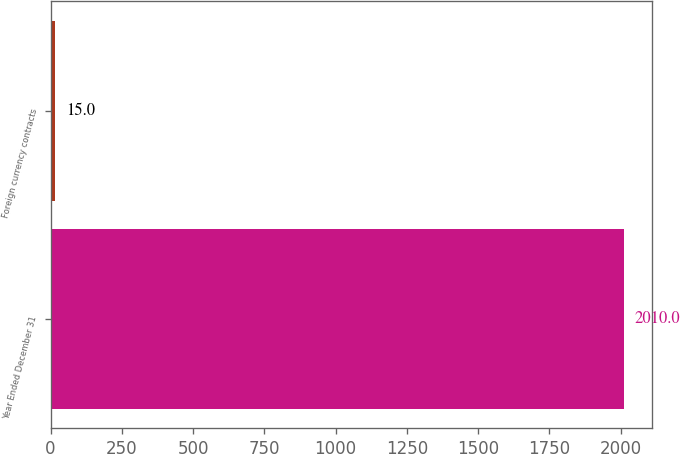Convert chart to OTSL. <chart><loc_0><loc_0><loc_500><loc_500><bar_chart><fcel>Year Ended December 31<fcel>Foreign currency contracts<nl><fcel>2010<fcel>15<nl></chart> 